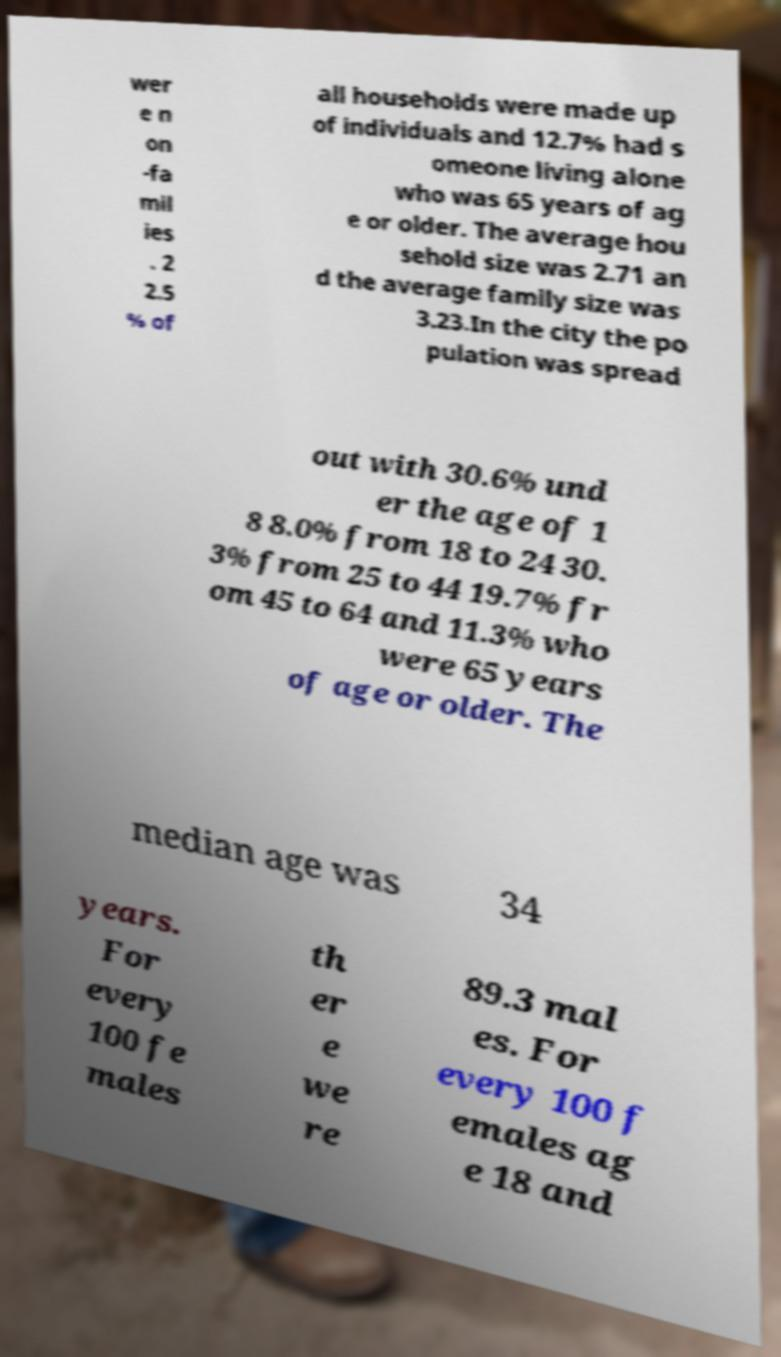Could you assist in decoding the text presented in this image and type it out clearly? wer e n on -fa mil ies . 2 2.5 % of all households were made up of individuals and 12.7% had s omeone living alone who was 65 years of ag e or older. The average hou sehold size was 2.71 an d the average family size was 3.23.In the city the po pulation was spread out with 30.6% und er the age of 1 8 8.0% from 18 to 24 30. 3% from 25 to 44 19.7% fr om 45 to 64 and 11.3% who were 65 years of age or older. The median age was 34 years. For every 100 fe males th er e we re 89.3 mal es. For every 100 f emales ag e 18 and 